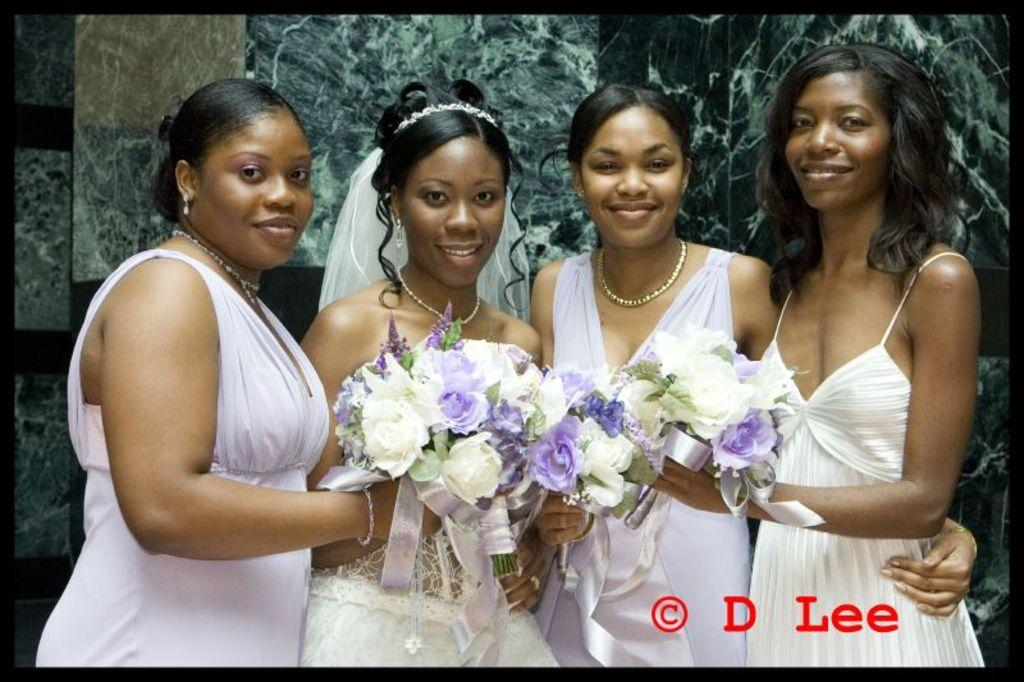What is the main subject of the image? The main subject of the image is a group of women. What are the women doing in the image? The women are standing and holding bouquets. What can be seen in the background of the image? There is a wall in the background of the image. Is there any text present in the image? Yes, there is text at the bottom of the image. What type of linen can be seen draped over the coast in the image? There is no coast or linen present in the image; it features a group of women standing and holding bouquets with a wall in the background and text at the bottom. 